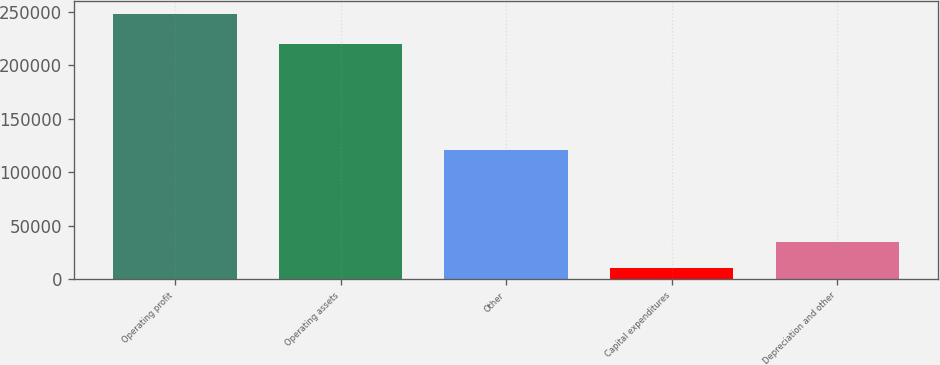Convert chart to OTSL. <chart><loc_0><loc_0><loc_500><loc_500><bar_chart><fcel>Operating profit<fcel>Operating assets<fcel>Other<fcel>Capital expenditures<fcel>Depreciation and other<nl><fcel>247596<fcel>220115<fcel>120681<fcel>10713<fcel>34401.3<nl></chart> 